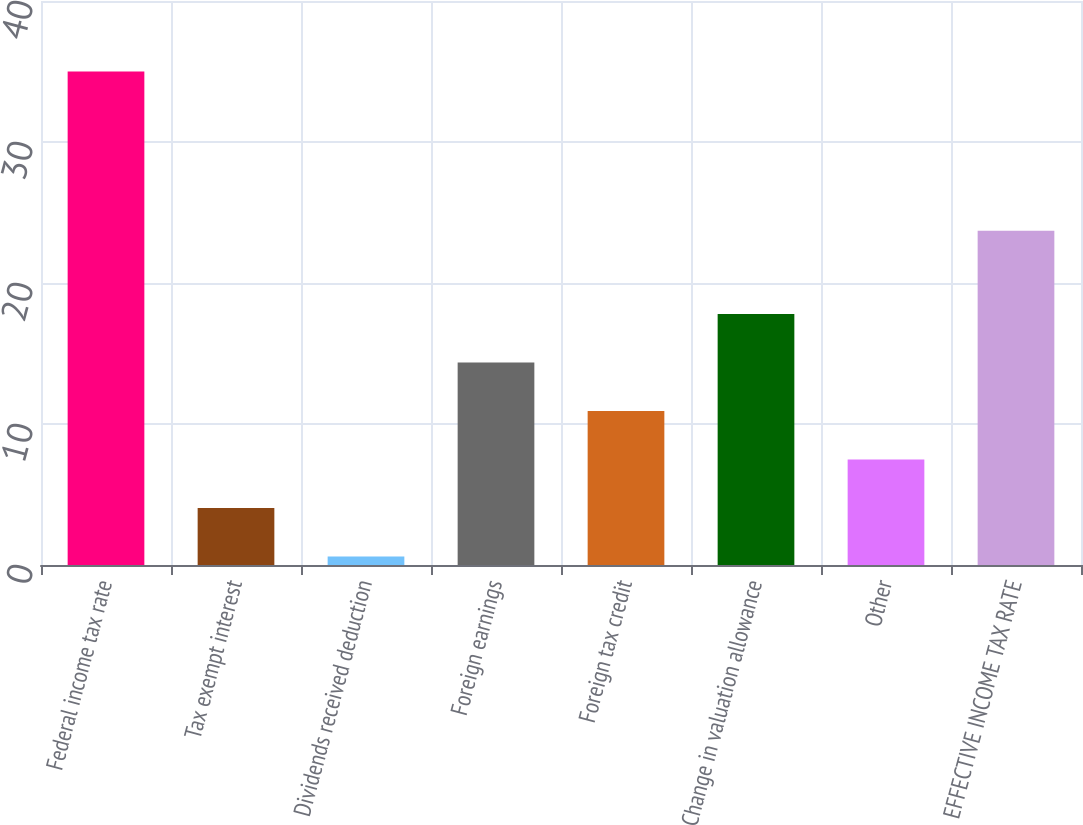Convert chart. <chart><loc_0><loc_0><loc_500><loc_500><bar_chart><fcel>Federal income tax rate<fcel>Tax exempt interest<fcel>Dividends received deduction<fcel>Foreign earnings<fcel>Foreign tax credit<fcel>Change in valuation allowance<fcel>Other<fcel>EFFECTIVE INCOME TAX RATE<nl><fcel>35<fcel>4.04<fcel>0.6<fcel>14.36<fcel>10.92<fcel>17.8<fcel>7.48<fcel>23.7<nl></chart> 